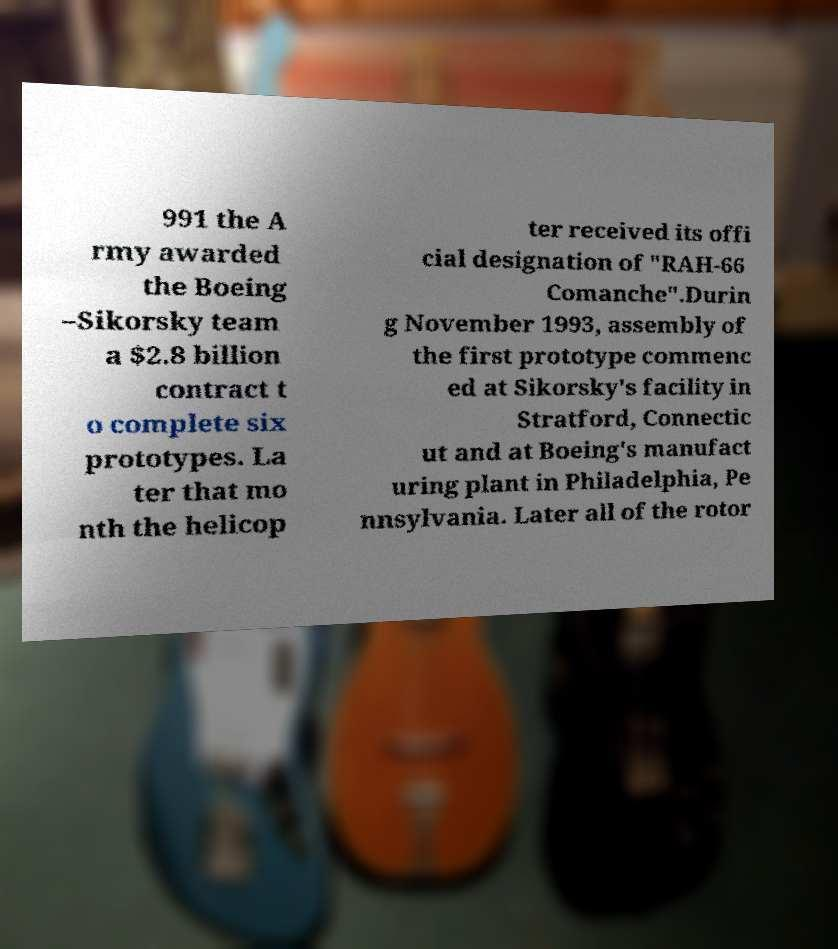Can you read and provide the text displayed in the image?This photo seems to have some interesting text. Can you extract and type it out for me? 991 the A rmy awarded the Boeing –Sikorsky team a $2.8 billion contract t o complete six prototypes. La ter that mo nth the helicop ter received its offi cial designation of "RAH-66 Comanche".Durin g November 1993, assembly of the first prototype commenc ed at Sikorsky's facility in Stratford, Connectic ut and at Boeing's manufact uring plant in Philadelphia, Pe nnsylvania. Later all of the rotor 